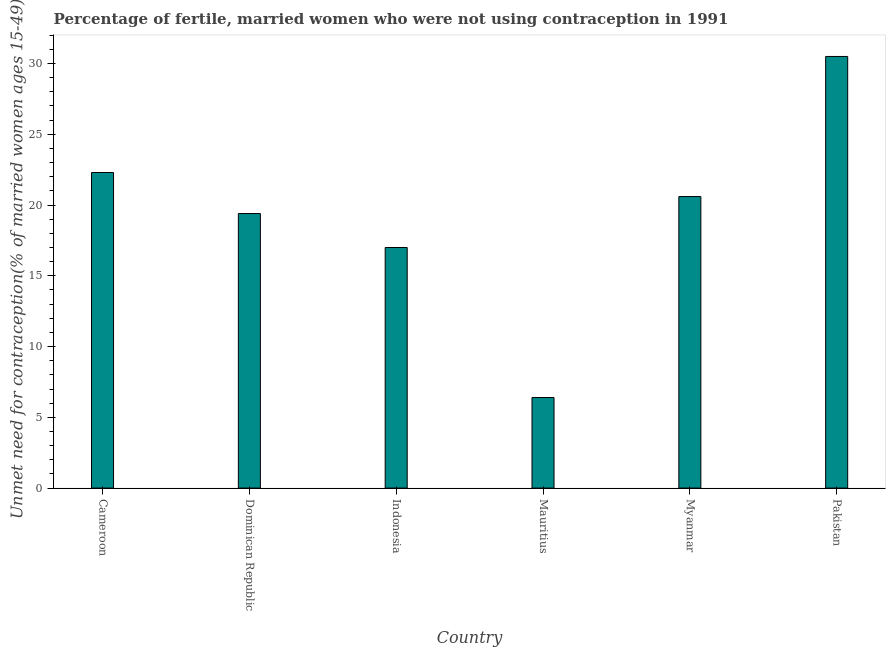Does the graph contain grids?
Offer a terse response. No. What is the title of the graph?
Offer a terse response. Percentage of fertile, married women who were not using contraception in 1991. What is the label or title of the X-axis?
Your answer should be very brief. Country. What is the label or title of the Y-axis?
Ensure brevity in your answer.   Unmet need for contraception(% of married women ages 15-49). What is the number of married women who are not using contraception in Cameroon?
Ensure brevity in your answer.  22.3. Across all countries, what is the maximum number of married women who are not using contraception?
Ensure brevity in your answer.  30.5. In which country was the number of married women who are not using contraception maximum?
Your answer should be compact. Pakistan. In which country was the number of married women who are not using contraception minimum?
Give a very brief answer. Mauritius. What is the sum of the number of married women who are not using contraception?
Keep it short and to the point. 116.2. What is the difference between the number of married women who are not using contraception in Cameroon and Myanmar?
Your answer should be very brief. 1.7. What is the average number of married women who are not using contraception per country?
Ensure brevity in your answer.  19.37. What is the median number of married women who are not using contraception?
Ensure brevity in your answer.  20. In how many countries, is the number of married women who are not using contraception greater than 3 %?
Keep it short and to the point. 6. What is the ratio of the number of married women who are not using contraception in Indonesia to that in Pakistan?
Give a very brief answer. 0.56. Is the difference between the number of married women who are not using contraception in Myanmar and Pakistan greater than the difference between any two countries?
Your answer should be compact. No. Is the sum of the number of married women who are not using contraception in Indonesia and Pakistan greater than the maximum number of married women who are not using contraception across all countries?
Provide a succinct answer. Yes. What is the difference between the highest and the lowest number of married women who are not using contraception?
Provide a short and direct response. 24.1. In how many countries, is the number of married women who are not using contraception greater than the average number of married women who are not using contraception taken over all countries?
Ensure brevity in your answer.  4. How many bars are there?
Your answer should be very brief. 6. Are all the bars in the graph horizontal?
Your answer should be compact. No. How many countries are there in the graph?
Provide a succinct answer. 6. What is the difference between two consecutive major ticks on the Y-axis?
Provide a short and direct response. 5. Are the values on the major ticks of Y-axis written in scientific E-notation?
Keep it short and to the point. No. What is the  Unmet need for contraception(% of married women ages 15-49) of Cameroon?
Ensure brevity in your answer.  22.3. What is the  Unmet need for contraception(% of married women ages 15-49) of Indonesia?
Offer a terse response. 17. What is the  Unmet need for contraception(% of married women ages 15-49) of Myanmar?
Your answer should be compact. 20.6. What is the  Unmet need for contraception(% of married women ages 15-49) of Pakistan?
Keep it short and to the point. 30.5. What is the difference between the  Unmet need for contraception(% of married women ages 15-49) in Cameroon and Mauritius?
Your response must be concise. 15.9. What is the difference between the  Unmet need for contraception(% of married women ages 15-49) in Indonesia and Myanmar?
Your answer should be very brief. -3.6. What is the difference between the  Unmet need for contraception(% of married women ages 15-49) in Mauritius and Pakistan?
Offer a very short reply. -24.1. What is the ratio of the  Unmet need for contraception(% of married women ages 15-49) in Cameroon to that in Dominican Republic?
Your answer should be compact. 1.15. What is the ratio of the  Unmet need for contraception(% of married women ages 15-49) in Cameroon to that in Indonesia?
Offer a very short reply. 1.31. What is the ratio of the  Unmet need for contraception(% of married women ages 15-49) in Cameroon to that in Mauritius?
Make the answer very short. 3.48. What is the ratio of the  Unmet need for contraception(% of married women ages 15-49) in Cameroon to that in Myanmar?
Make the answer very short. 1.08. What is the ratio of the  Unmet need for contraception(% of married women ages 15-49) in Cameroon to that in Pakistan?
Offer a terse response. 0.73. What is the ratio of the  Unmet need for contraception(% of married women ages 15-49) in Dominican Republic to that in Indonesia?
Provide a succinct answer. 1.14. What is the ratio of the  Unmet need for contraception(% of married women ages 15-49) in Dominican Republic to that in Mauritius?
Your response must be concise. 3.03. What is the ratio of the  Unmet need for contraception(% of married women ages 15-49) in Dominican Republic to that in Myanmar?
Your answer should be compact. 0.94. What is the ratio of the  Unmet need for contraception(% of married women ages 15-49) in Dominican Republic to that in Pakistan?
Your response must be concise. 0.64. What is the ratio of the  Unmet need for contraception(% of married women ages 15-49) in Indonesia to that in Mauritius?
Your response must be concise. 2.66. What is the ratio of the  Unmet need for contraception(% of married women ages 15-49) in Indonesia to that in Myanmar?
Make the answer very short. 0.82. What is the ratio of the  Unmet need for contraception(% of married women ages 15-49) in Indonesia to that in Pakistan?
Keep it short and to the point. 0.56. What is the ratio of the  Unmet need for contraception(% of married women ages 15-49) in Mauritius to that in Myanmar?
Offer a terse response. 0.31. What is the ratio of the  Unmet need for contraception(% of married women ages 15-49) in Mauritius to that in Pakistan?
Keep it short and to the point. 0.21. What is the ratio of the  Unmet need for contraception(% of married women ages 15-49) in Myanmar to that in Pakistan?
Keep it short and to the point. 0.68. 